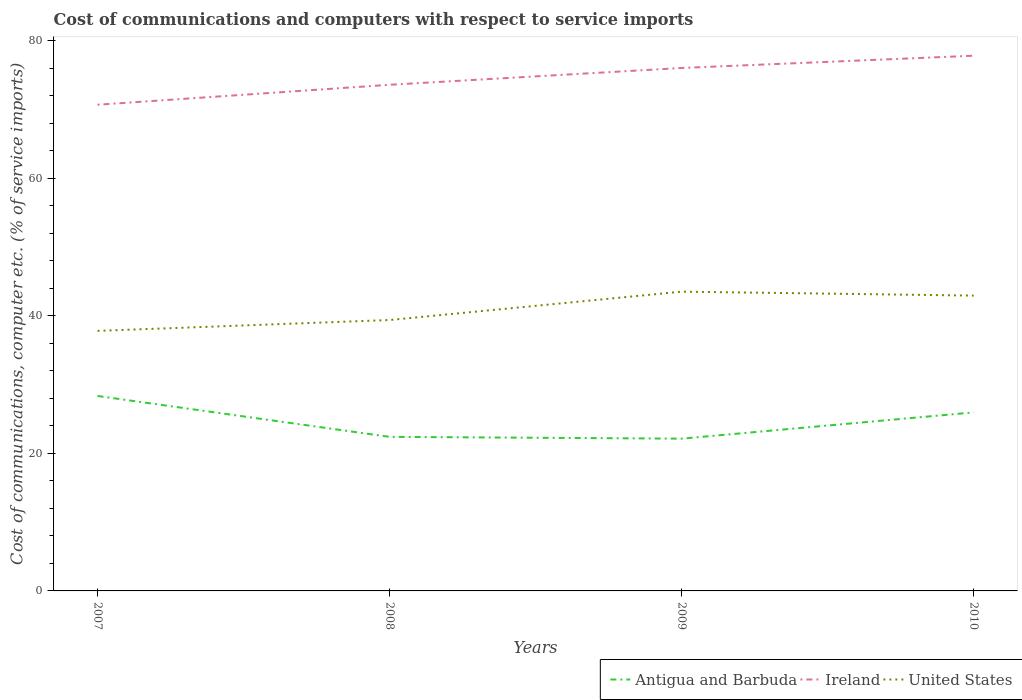How many different coloured lines are there?
Keep it short and to the point. 3. Does the line corresponding to Antigua and Barbuda intersect with the line corresponding to Ireland?
Your answer should be compact. No. Across all years, what is the maximum cost of communications and computers in Ireland?
Your answer should be compact. 70.68. What is the total cost of communications and computers in United States in the graph?
Ensure brevity in your answer.  -4.12. What is the difference between the highest and the second highest cost of communications and computers in United States?
Provide a succinct answer. 5.7. How many lines are there?
Provide a succinct answer. 3. How many years are there in the graph?
Your answer should be very brief. 4. Are the values on the major ticks of Y-axis written in scientific E-notation?
Offer a terse response. No. Does the graph contain any zero values?
Make the answer very short. No. Does the graph contain grids?
Your response must be concise. No. Where does the legend appear in the graph?
Give a very brief answer. Bottom right. How many legend labels are there?
Offer a very short reply. 3. What is the title of the graph?
Make the answer very short. Cost of communications and computers with respect to service imports. What is the label or title of the Y-axis?
Provide a short and direct response. Cost of communications, computer etc. (% of service imports). What is the Cost of communications, computer etc. (% of service imports) of Antigua and Barbuda in 2007?
Ensure brevity in your answer.  28.34. What is the Cost of communications, computer etc. (% of service imports) of Ireland in 2007?
Make the answer very short. 70.68. What is the Cost of communications, computer etc. (% of service imports) of United States in 2007?
Give a very brief answer. 37.8. What is the Cost of communications, computer etc. (% of service imports) in Antigua and Barbuda in 2008?
Your answer should be compact. 22.4. What is the Cost of communications, computer etc. (% of service imports) of Ireland in 2008?
Your answer should be very brief. 73.58. What is the Cost of communications, computer etc. (% of service imports) of United States in 2008?
Provide a short and direct response. 39.38. What is the Cost of communications, computer etc. (% of service imports) of Antigua and Barbuda in 2009?
Ensure brevity in your answer.  22.14. What is the Cost of communications, computer etc. (% of service imports) of Ireland in 2009?
Your answer should be very brief. 76.03. What is the Cost of communications, computer etc. (% of service imports) of United States in 2009?
Ensure brevity in your answer.  43.51. What is the Cost of communications, computer etc. (% of service imports) in Antigua and Barbuda in 2010?
Provide a short and direct response. 25.95. What is the Cost of communications, computer etc. (% of service imports) in Ireland in 2010?
Make the answer very short. 77.81. What is the Cost of communications, computer etc. (% of service imports) in United States in 2010?
Ensure brevity in your answer.  42.93. Across all years, what is the maximum Cost of communications, computer etc. (% of service imports) in Antigua and Barbuda?
Offer a terse response. 28.34. Across all years, what is the maximum Cost of communications, computer etc. (% of service imports) of Ireland?
Provide a short and direct response. 77.81. Across all years, what is the maximum Cost of communications, computer etc. (% of service imports) of United States?
Provide a succinct answer. 43.51. Across all years, what is the minimum Cost of communications, computer etc. (% of service imports) of Antigua and Barbuda?
Your response must be concise. 22.14. Across all years, what is the minimum Cost of communications, computer etc. (% of service imports) in Ireland?
Your response must be concise. 70.68. Across all years, what is the minimum Cost of communications, computer etc. (% of service imports) in United States?
Provide a succinct answer. 37.8. What is the total Cost of communications, computer etc. (% of service imports) in Antigua and Barbuda in the graph?
Your response must be concise. 98.83. What is the total Cost of communications, computer etc. (% of service imports) of Ireland in the graph?
Offer a terse response. 298.1. What is the total Cost of communications, computer etc. (% of service imports) in United States in the graph?
Give a very brief answer. 163.63. What is the difference between the Cost of communications, computer etc. (% of service imports) of Antigua and Barbuda in 2007 and that in 2008?
Ensure brevity in your answer.  5.95. What is the difference between the Cost of communications, computer etc. (% of service imports) of Ireland in 2007 and that in 2008?
Keep it short and to the point. -2.9. What is the difference between the Cost of communications, computer etc. (% of service imports) in United States in 2007 and that in 2008?
Your answer should be very brief. -1.58. What is the difference between the Cost of communications, computer etc. (% of service imports) of Antigua and Barbuda in 2007 and that in 2009?
Offer a very short reply. 6.21. What is the difference between the Cost of communications, computer etc. (% of service imports) of Ireland in 2007 and that in 2009?
Make the answer very short. -5.34. What is the difference between the Cost of communications, computer etc. (% of service imports) of United States in 2007 and that in 2009?
Make the answer very short. -5.7. What is the difference between the Cost of communications, computer etc. (% of service imports) of Antigua and Barbuda in 2007 and that in 2010?
Ensure brevity in your answer.  2.39. What is the difference between the Cost of communications, computer etc. (% of service imports) of Ireland in 2007 and that in 2010?
Your answer should be compact. -7.13. What is the difference between the Cost of communications, computer etc. (% of service imports) of United States in 2007 and that in 2010?
Give a very brief answer. -5.13. What is the difference between the Cost of communications, computer etc. (% of service imports) in Antigua and Barbuda in 2008 and that in 2009?
Ensure brevity in your answer.  0.26. What is the difference between the Cost of communications, computer etc. (% of service imports) of Ireland in 2008 and that in 2009?
Your answer should be compact. -2.44. What is the difference between the Cost of communications, computer etc. (% of service imports) in United States in 2008 and that in 2009?
Ensure brevity in your answer.  -4.12. What is the difference between the Cost of communications, computer etc. (% of service imports) of Antigua and Barbuda in 2008 and that in 2010?
Offer a terse response. -3.56. What is the difference between the Cost of communications, computer etc. (% of service imports) of Ireland in 2008 and that in 2010?
Ensure brevity in your answer.  -4.22. What is the difference between the Cost of communications, computer etc. (% of service imports) in United States in 2008 and that in 2010?
Your answer should be compact. -3.55. What is the difference between the Cost of communications, computer etc. (% of service imports) of Antigua and Barbuda in 2009 and that in 2010?
Provide a succinct answer. -3.82. What is the difference between the Cost of communications, computer etc. (% of service imports) of Ireland in 2009 and that in 2010?
Make the answer very short. -1.78. What is the difference between the Cost of communications, computer etc. (% of service imports) in United States in 2009 and that in 2010?
Ensure brevity in your answer.  0.57. What is the difference between the Cost of communications, computer etc. (% of service imports) of Antigua and Barbuda in 2007 and the Cost of communications, computer etc. (% of service imports) of Ireland in 2008?
Offer a very short reply. -45.24. What is the difference between the Cost of communications, computer etc. (% of service imports) in Antigua and Barbuda in 2007 and the Cost of communications, computer etc. (% of service imports) in United States in 2008?
Your answer should be compact. -11.04. What is the difference between the Cost of communications, computer etc. (% of service imports) in Ireland in 2007 and the Cost of communications, computer etc. (% of service imports) in United States in 2008?
Provide a succinct answer. 31.3. What is the difference between the Cost of communications, computer etc. (% of service imports) in Antigua and Barbuda in 2007 and the Cost of communications, computer etc. (% of service imports) in Ireland in 2009?
Your response must be concise. -47.68. What is the difference between the Cost of communications, computer etc. (% of service imports) of Antigua and Barbuda in 2007 and the Cost of communications, computer etc. (% of service imports) of United States in 2009?
Your response must be concise. -15.17. What is the difference between the Cost of communications, computer etc. (% of service imports) of Ireland in 2007 and the Cost of communications, computer etc. (% of service imports) of United States in 2009?
Ensure brevity in your answer.  27.17. What is the difference between the Cost of communications, computer etc. (% of service imports) in Antigua and Barbuda in 2007 and the Cost of communications, computer etc. (% of service imports) in Ireland in 2010?
Provide a short and direct response. -49.46. What is the difference between the Cost of communications, computer etc. (% of service imports) of Antigua and Barbuda in 2007 and the Cost of communications, computer etc. (% of service imports) of United States in 2010?
Give a very brief answer. -14.59. What is the difference between the Cost of communications, computer etc. (% of service imports) of Ireland in 2007 and the Cost of communications, computer etc. (% of service imports) of United States in 2010?
Give a very brief answer. 27.75. What is the difference between the Cost of communications, computer etc. (% of service imports) of Antigua and Barbuda in 2008 and the Cost of communications, computer etc. (% of service imports) of Ireland in 2009?
Your answer should be very brief. -53.63. What is the difference between the Cost of communications, computer etc. (% of service imports) of Antigua and Barbuda in 2008 and the Cost of communications, computer etc. (% of service imports) of United States in 2009?
Offer a very short reply. -21.11. What is the difference between the Cost of communications, computer etc. (% of service imports) of Ireland in 2008 and the Cost of communications, computer etc. (% of service imports) of United States in 2009?
Keep it short and to the point. 30.07. What is the difference between the Cost of communications, computer etc. (% of service imports) in Antigua and Barbuda in 2008 and the Cost of communications, computer etc. (% of service imports) in Ireland in 2010?
Give a very brief answer. -55.41. What is the difference between the Cost of communications, computer etc. (% of service imports) in Antigua and Barbuda in 2008 and the Cost of communications, computer etc. (% of service imports) in United States in 2010?
Your answer should be compact. -20.54. What is the difference between the Cost of communications, computer etc. (% of service imports) of Ireland in 2008 and the Cost of communications, computer etc. (% of service imports) of United States in 2010?
Provide a short and direct response. 30.65. What is the difference between the Cost of communications, computer etc. (% of service imports) in Antigua and Barbuda in 2009 and the Cost of communications, computer etc. (% of service imports) in Ireland in 2010?
Offer a very short reply. -55.67. What is the difference between the Cost of communications, computer etc. (% of service imports) of Antigua and Barbuda in 2009 and the Cost of communications, computer etc. (% of service imports) of United States in 2010?
Your response must be concise. -20.8. What is the difference between the Cost of communications, computer etc. (% of service imports) in Ireland in 2009 and the Cost of communications, computer etc. (% of service imports) in United States in 2010?
Keep it short and to the point. 33.09. What is the average Cost of communications, computer etc. (% of service imports) in Antigua and Barbuda per year?
Your answer should be compact. 24.71. What is the average Cost of communications, computer etc. (% of service imports) of Ireland per year?
Offer a terse response. 74.52. What is the average Cost of communications, computer etc. (% of service imports) of United States per year?
Ensure brevity in your answer.  40.91. In the year 2007, what is the difference between the Cost of communications, computer etc. (% of service imports) in Antigua and Barbuda and Cost of communications, computer etc. (% of service imports) in Ireland?
Provide a short and direct response. -42.34. In the year 2007, what is the difference between the Cost of communications, computer etc. (% of service imports) of Antigua and Barbuda and Cost of communications, computer etc. (% of service imports) of United States?
Offer a very short reply. -9.46. In the year 2007, what is the difference between the Cost of communications, computer etc. (% of service imports) in Ireland and Cost of communications, computer etc. (% of service imports) in United States?
Ensure brevity in your answer.  32.88. In the year 2008, what is the difference between the Cost of communications, computer etc. (% of service imports) of Antigua and Barbuda and Cost of communications, computer etc. (% of service imports) of Ireland?
Your answer should be compact. -51.18. In the year 2008, what is the difference between the Cost of communications, computer etc. (% of service imports) in Antigua and Barbuda and Cost of communications, computer etc. (% of service imports) in United States?
Ensure brevity in your answer.  -16.99. In the year 2008, what is the difference between the Cost of communications, computer etc. (% of service imports) in Ireland and Cost of communications, computer etc. (% of service imports) in United States?
Offer a terse response. 34.2. In the year 2009, what is the difference between the Cost of communications, computer etc. (% of service imports) in Antigua and Barbuda and Cost of communications, computer etc. (% of service imports) in Ireland?
Give a very brief answer. -53.89. In the year 2009, what is the difference between the Cost of communications, computer etc. (% of service imports) of Antigua and Barbuda and Cost of communications, computer etc. (% of service imports) of United States?
Give a very brief answer. -21.37. In the year 2009, what is the difference between the Cost of communications, computer etc. (% of service imports) in Ireland and Cost of communications, computer etc. (% of service imports) in United States?
Make the answer very short. 32.52. In the year 2010, what is the difference between the Cost of communications, computer etc. (% of service imports) of Antigua and Barbuda and Cost of communications, computer etc. (% of service imports) of Ireland?
Your answer should be very brief. -51.85. In the year 2010, what is the difference between the Cost of communications, computer etc. (% of service imports) in Antigua and Barbuda and Cost of communications, computer etc. (% of service imports) in United States?
Make the answer very short. -16.98. In the year 2010, what is the difference between the Cost of communications, computer etc. (% of service imports) in Ireland and Cost of communications, computer etc. (% of service imports) in United States?
Provide a succinct answer. 34.87. What is the ratio of the Cost of communications, computer etc. (% of service imports) of Antigua and Barbuda in 2007 to that in 2008?
Keep it short and to the point. 1.27. What is the ratio of the Cost of communications, computer etc. (% of service imports) of Ireland in 2007 to that in 2008?
Ensure brevity in your answer.  0.96. What is the ratio of the Cost of communications, computer etc. (% of service imports) in United States in 2007 to that in 2008?
Offer a terse response. 0.96. What is the ratio of the Cost of communications, computer etc. (% of service imports) of Antigua and Barbuda in 2007 to that in 2009?
Ensure brevity in your answer.  1.28. What is the ratio of the Cost of communications, computer etc. (% of service imports) in Ireland in 2007 to that in 2009?
Give a very brief answer. 0.93. What is the ratio of the Cost of communications, computer etc. (% of service imports) in United States in 2007 to that in 2009?
Offer a very short reply. 0.87. What is the ratio of the Cost of communications, computer etc. (% of service imports) of Antigua and Barbuda in 2007 to that in 2010?
Keep it short and to the point. 1.09. What is the ratio of the Cost of communications, computer etc. (% of service imports) in Ireland in 2007 to that in 2010?
Your response must be concise. 0.91. What is the ratio of the Cost of communications, computer etc. (% of service imports) in United States in 2007 to that in 2010?
Give a very brief answer. 0.88. What is the ratio of the Cost of communications, computer etc. (% of service imports) of Antigua and Barbuda in 2008 to that in 2009?
Provide a succinct answer. 1.01. What is the ratio of the Cost of communications, computer etc. (% of service imports) of Ireland in 2008 to that in 2009?
Provide a succinct answer. 0.97. What is the ratio of the Cost of communications, computer etc. (% of service imports) in United States in 2008 to that in 2009?
Give a very brief answer. 0.91. What is the ratio of the Cost of communications, computer etc. (% of service imports) of Antigua and Barbuda in 2008 to that in 2010?
Offer a terse response. 0.86. What is the ratio of the Cost of communications, computer etc. (% of service imports) of Ireland in 2008 to that in 2010?
Your answer should be very brief. 0.95. What is the ratio of the Cost of communications, computer etc. (% of service imports) in United States in 2008 to that in 2010?
Provide a short and direct response. 0.92. What is the ratio of the Cost of communications, computer etc. (% of service imports) of Antigua and Barbuda in 2009 to that in 2010?
Provide a short and direct response. 0.85. What is the ratio of the Cost of communications, computer etc. (% of service imports) of Ireland in 2009 to that in 2010?
Your answer should be compact. 0.98. What is the ratio of the Cost of communications, computer etc. (% of service imports) of United States in 2009 to that in 2010?
Provide a succinct answer. 1.01. What is the difference between the highest and the second highest Cost of communications, computer etc. (% of service imports) in Antigua and Barbuda?
Provide a succinct answer. 2.39. What is the difference between the highest and the second highest Cost of communications, computer etc. (% of service imports) of Ireland?
Ensure brevity in your answer.  1.78. What is the difference between the highest and the second highest Cost of communications, computer etc. (% of service imports) of United States?
Offer a very short reply. 0.57. What is the difference between the highest and the lowest Cost of communications, computer etc. (% of service imports) of Antigua and Barbuda?
Your answer should be compact. 6.21. What is the difference between the highest and the lowest Cost of communications, computer etc. (% of service imports) in Ireland?
Provide a short and direct response. 7.13. What is the difference between the highest and the lowest Cost of communications, computer etc. (% of service imports) in United States?
Make the answer very short. 5.7. 